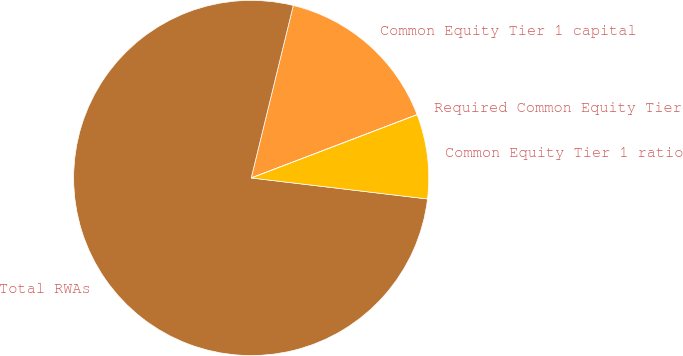Convert chart. <chart><loc_0><loc_0><loc_500><loc_500><pie_chart><fcel>Common Equity Tier 1 capital<fcel>Total RWAs<fcel>Common Equity Tier 1 ratio<fcel>Required Common Equity Tier 1<nl><fcel>15.39%<fcel>76.92%<fcel>7.69%<fcel>0.0%<nl></chart> 